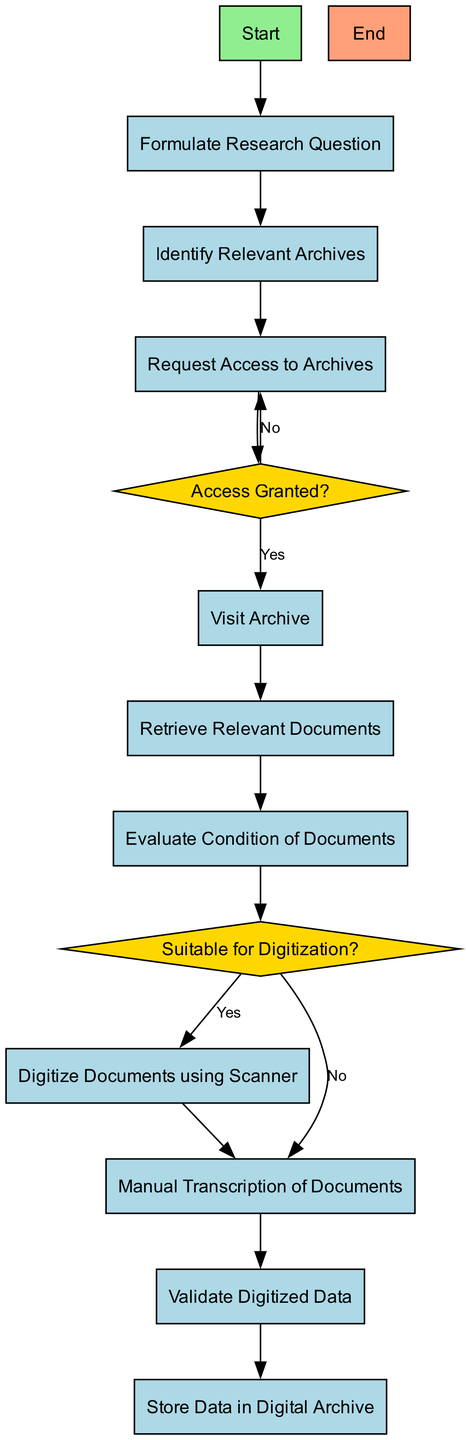What is the first step in the workflow? The first step is denoted by the "Start" node, which is the initial point of the workflow diagram.
Answer: Start How many decision nodes are present in the diagram? There are two decision nodes in the workflow: "Access Granted?" and "Suitable for Digitization?".
Answer: 2 Which node follows "Request Access to Archives" if access is granted? If access is granted, the next process is "Visit Archive," which is linked directly from the decision node "Access Granted?".
Answer: Visit Archive What should you do if the documents are not suitable for digitization? If the documents are not suitable for digitization, the workflow directs you to "Manual Transcription of Documents."
Answer: Manual Transcription of Documents What action is taken after retrieving relevant documents? After retrieving relevant documents, the workflow proceeds to "Evaluate Condition of Documents," as indicated by their sequential relationship in the diagram.
Answer: Evaluate Condition of Documents If access to the archives is denied, what is the next step? If access is denied, the workflow loops back to "Request Access to Archives," indicating the need to attempt access again.
Answer: Request Access to Archives How many processes are there in total in the workflow? Counting the nodes labeled as processes, there are eight processes in total within the workflow.
Answer: 8 Which node directly follows "Digitize Documents using Scanner"? "Validate Digitized Data" follows directly after "Digitize Documents using Scanner," connecting the action of digitization to the validation step.
Answer: Validate Digitized Data 